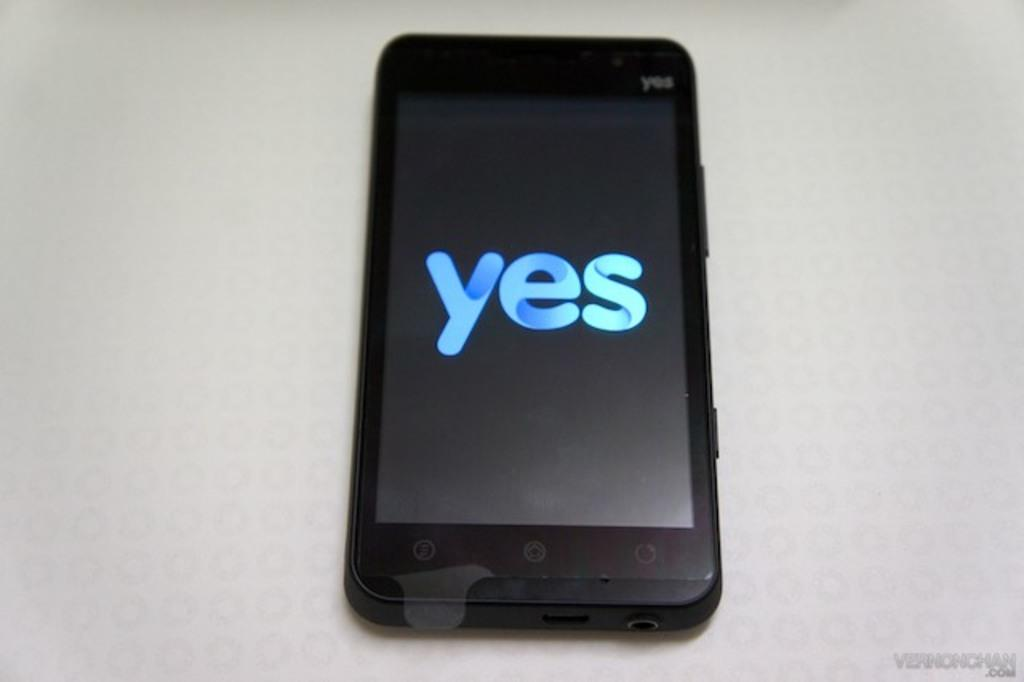Provide a one-sentence caption for the provided image. A yes brand cell phone with the display screen reading yes. 